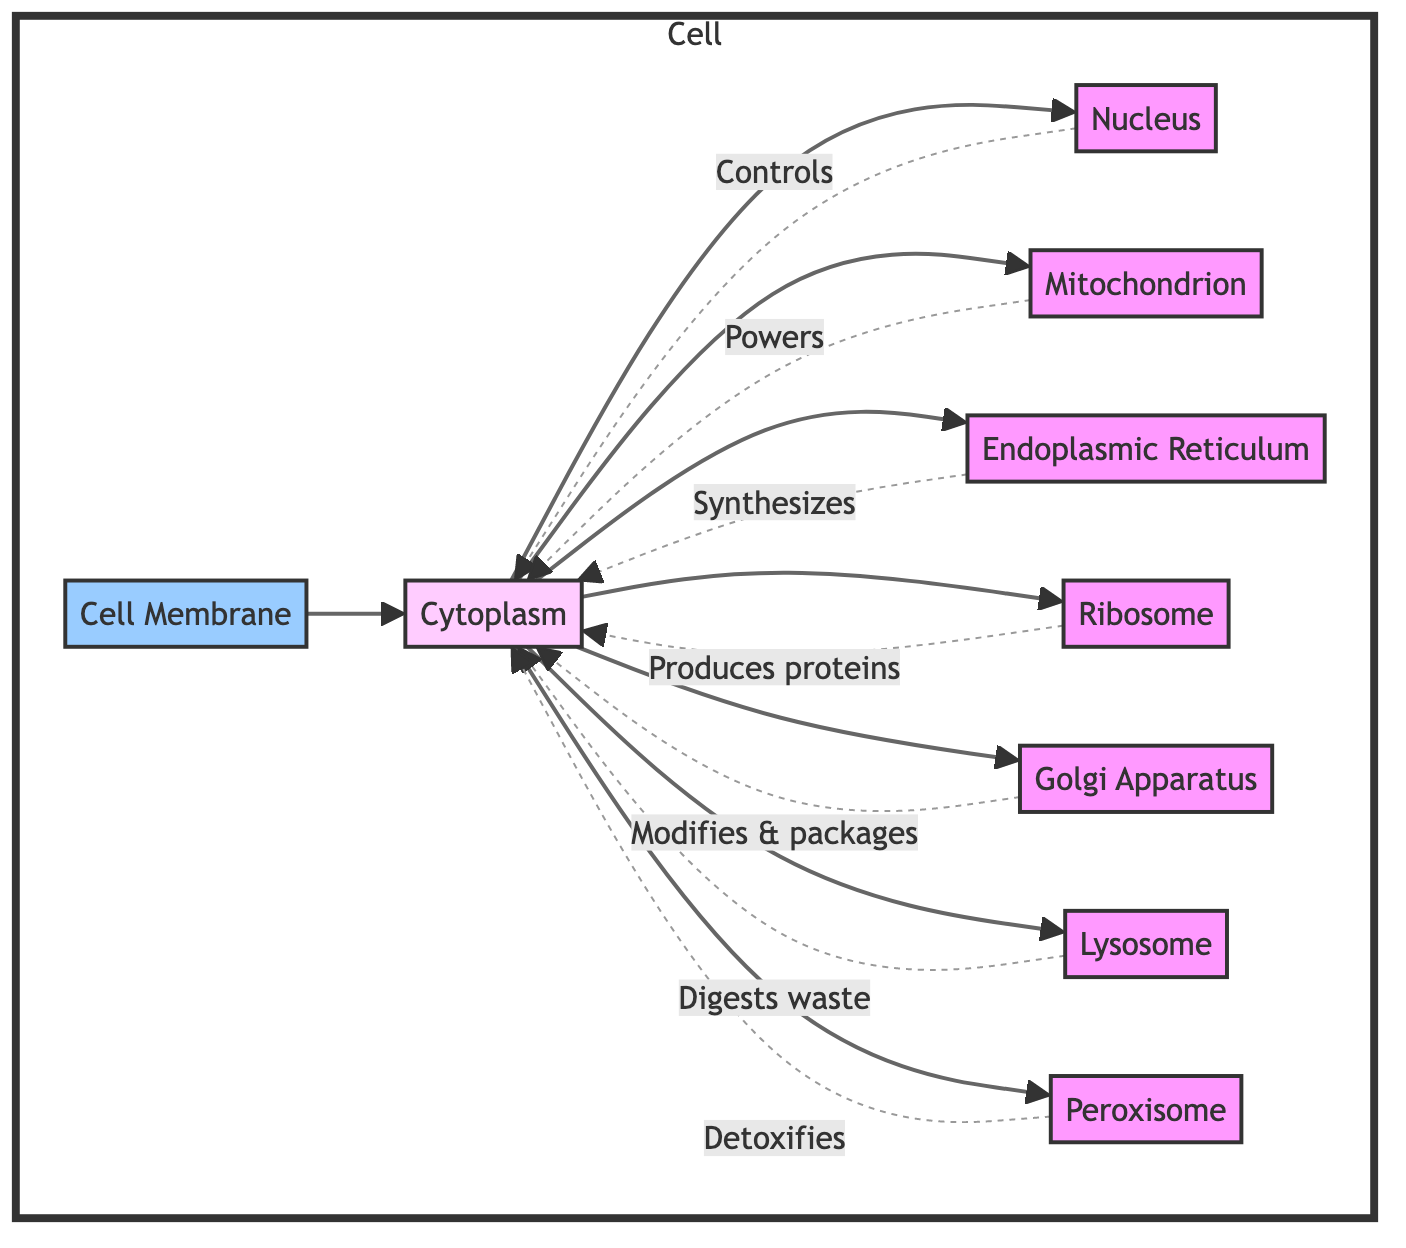What is the total number of organelles shown in the diagram? The diagram shows eight compartments labeled as organelles connected to the cytoplasm: Nucleus, Mitochondrion, Endoplasmic Reticulum, Ribosome, Golgi Apparatus, Lysosome, and Peroxisome. Counting these gives a total of eight organelles.
Answer: 8 Which organelle is responsible for producing proteins? The diagram indicates that Ribosome is the organelle directly responsible for "produces proteins" in its connection to the cytoplasm, as it is linked by an arrow labeled "Produces proteins."
Answer: Ribosome What is the function of the Golgi Apparatus? The diagram states that the Golgi Apparatus is responsible for modifying and packaging proteins, as indicated by the labeled dashed line connecting it to the cytoplasm.
Answer: Modifies & packages How many organelles are directly connected to the Cytoplasm? From the diagram, the Cytoplasm is connected to eight compartments, all of which are indicated by arrows pointing towards the Cytoplasm, suggesting direct connections.
Answer: 8 Which organelle is referred to as the power source of the cell? The diagram identifies Mitochondrion with the label "Powers," suggesting it is the organelle that serves as the power source for the entire cell structure.
Answer: Mitochondrion Which organelle is responsible for detoxification? The flowchart indicates that the Peroxisome has a connection with the label "Detoxifies," indicating its role in detoxifying harmful substances within the cell cytoplasm.
Answer: Peroxisome Identify one organelle that digests waste. The diagram states that the Lysosome is responsible for digestion of waste material within the cell, which confirms its role in waste management.
Answer: Lysosome What role does the Nucleus play in the cell? The diagram connects the Nucleus to the Cytoplasm with a dashed line labeled "Controls," indicating that it serves a controlling or regulatory function over the cellular processes.
Answer: Controls 